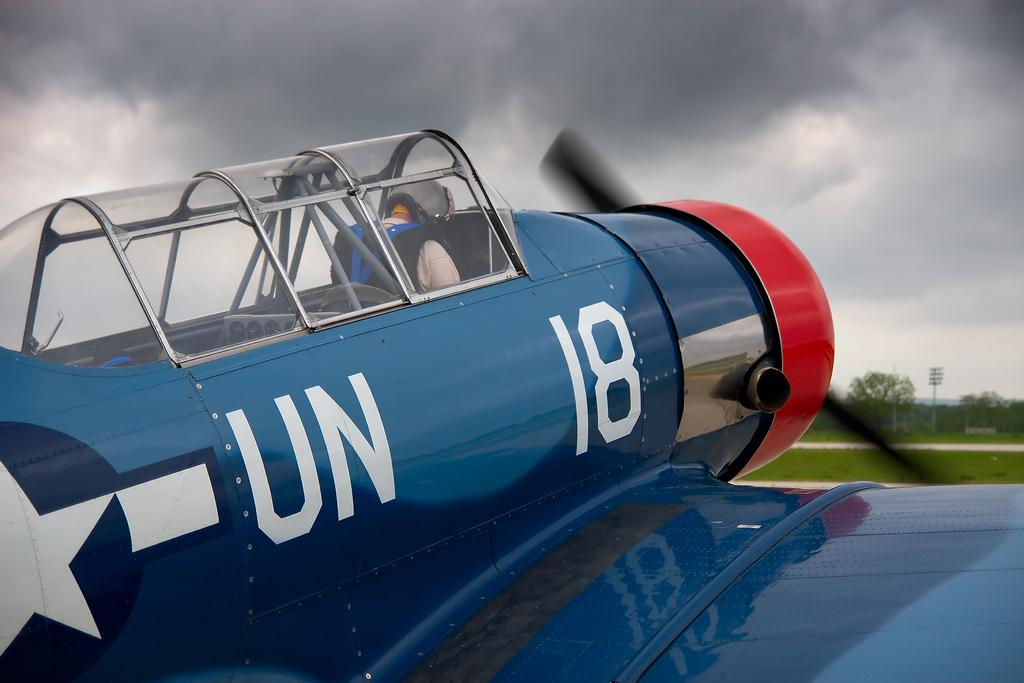<image>
Present a compact description of the photo's key features. UN 18 marked old American fighter plane from WW2 